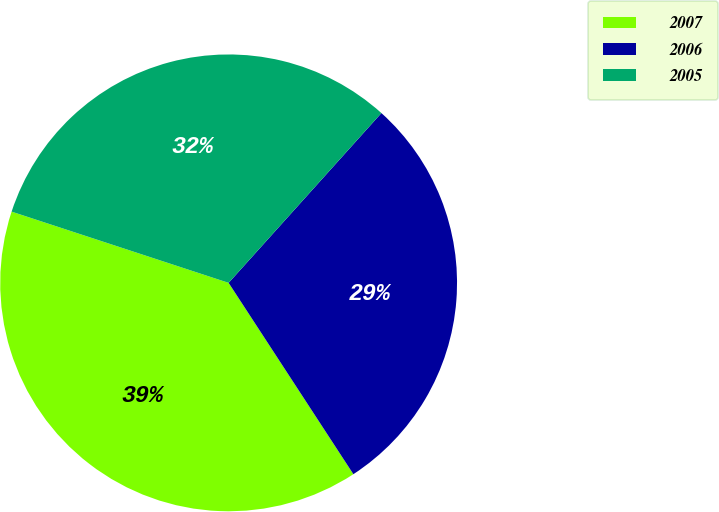<chart> <loc_0><loc_0><loc_500><loc_500><pie_chart><fcel>2007<fcel>2006<fcel>2005<nl><fcel>39.24%<fcel>29.14%<fcel>31.61%<nl></chart> 